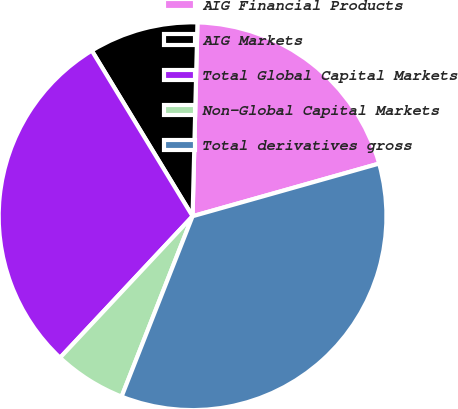Convert chart. <chart><loc_0><loc_0><loc_500><loc_500><pie_chart><fcel>AIG Financial Products<fcel>AIG Markets<fcel>Total Global Capital Markets<fcel>Non-Global Capital Markets<fcel>Total derivatives gross<nl><fcel>20.22%<fcel>9.1%<fcel>29.32%<fcel>6.01%<fcel>35.34%<nl></chart> 